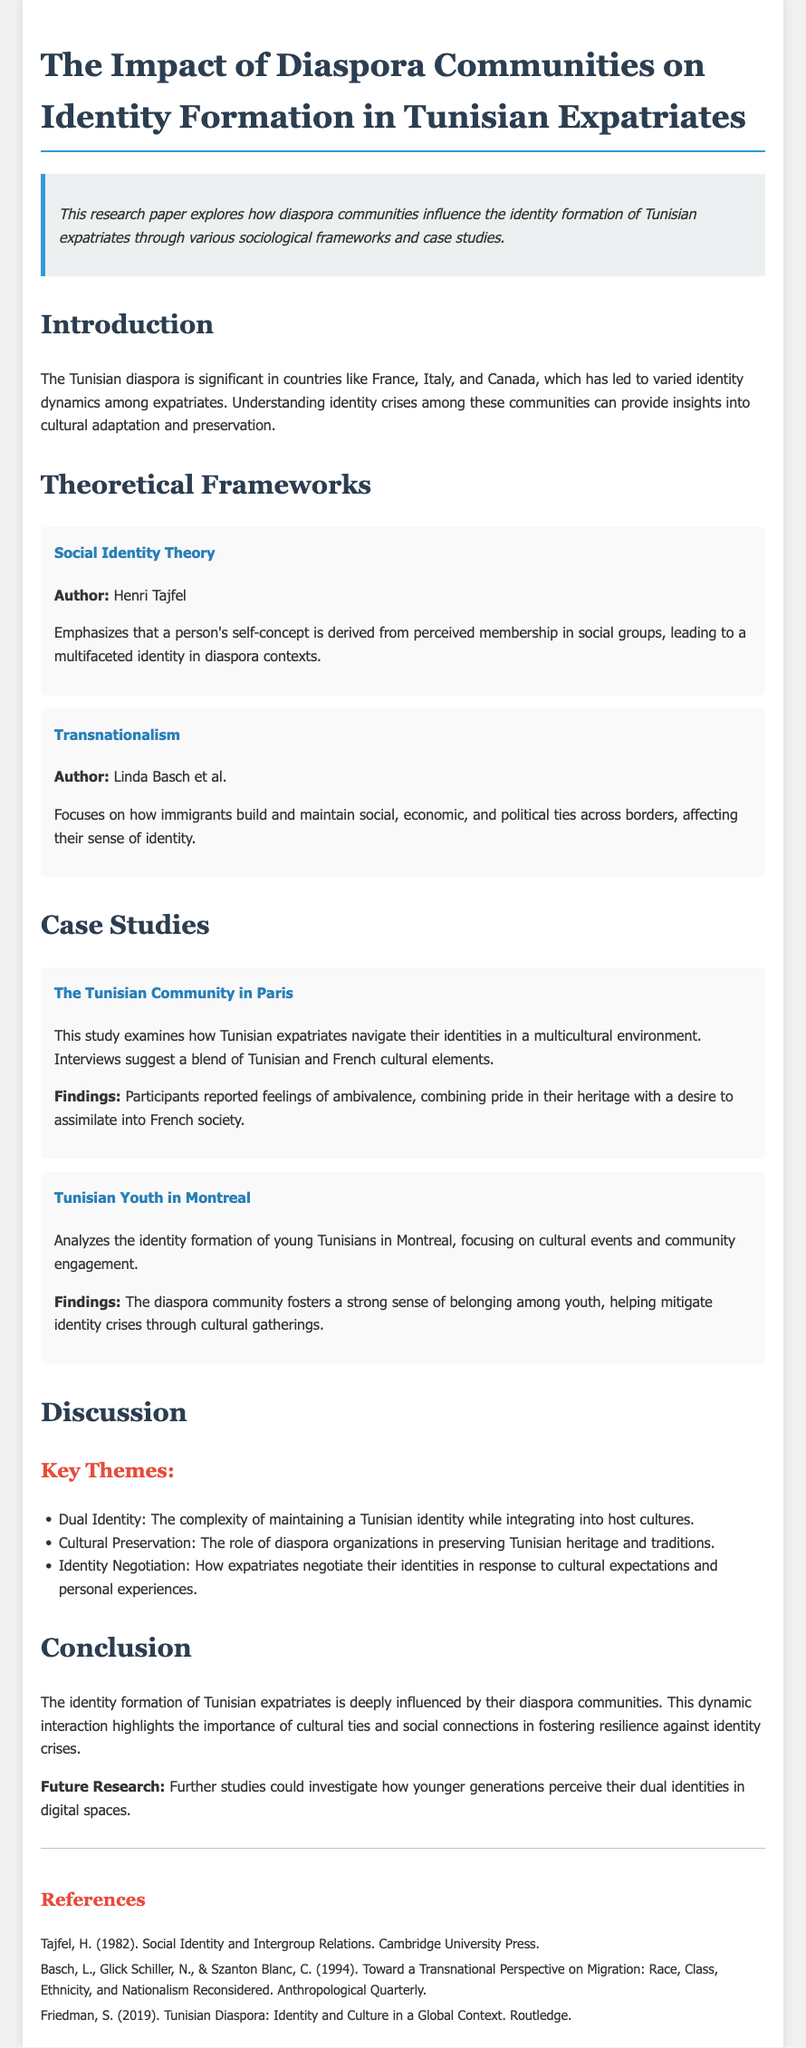What is the title of the research paper? The title of the research paper is explicitly stated at the beginning of the document.
Answer: The Impact of Diaspora Communities on Identity Formation in Tunisian Expatriates Who is the author of Social Identity Theory? The document lists Henri Tajfel as the author of Social Identity Theory in the theoretical frameworks section.
Answer: Henri Tajfel What city is mentioned in the case study about Tunisian expatriates? The document refers specifically to Paris in the case study section concerning Tunisian expatriates.
Answer: Paris What is one key theme discussed in the paper? The paper lists several themes in the discussion section, including the complexity of identity.
Answer: Dual Identity What is the publication year of the work by Tajfel referenced in the references? The reference section provides the publication year of Tajfel's work as 1982.
Answer: 1982 What is the main focus of Linda Basch's theory discussed in the paper? The document describes Basch's theory in relation to immigrants and their connections across borders, emphasizing its impact on identity.
Answer: Transnationalism What type of events help mitigate identity crises among Tunisian youth in Montreal? The document describes cultural gatherings as significant events for the Tunisian youth community in Montreal that foster belonging.
Answer: Cultural gatherings What is the conclusion drawn about the identity formation of Tunisian expatriates? The conclusion in the paper emphasizes the influential role of diaspora communities on identity formation.
Answer: Influenced by diaspora communities In what type of document format is this research presented? The structure and formatting of the document indicate it is a research paper or scholarly article.
Answer: Research paper 